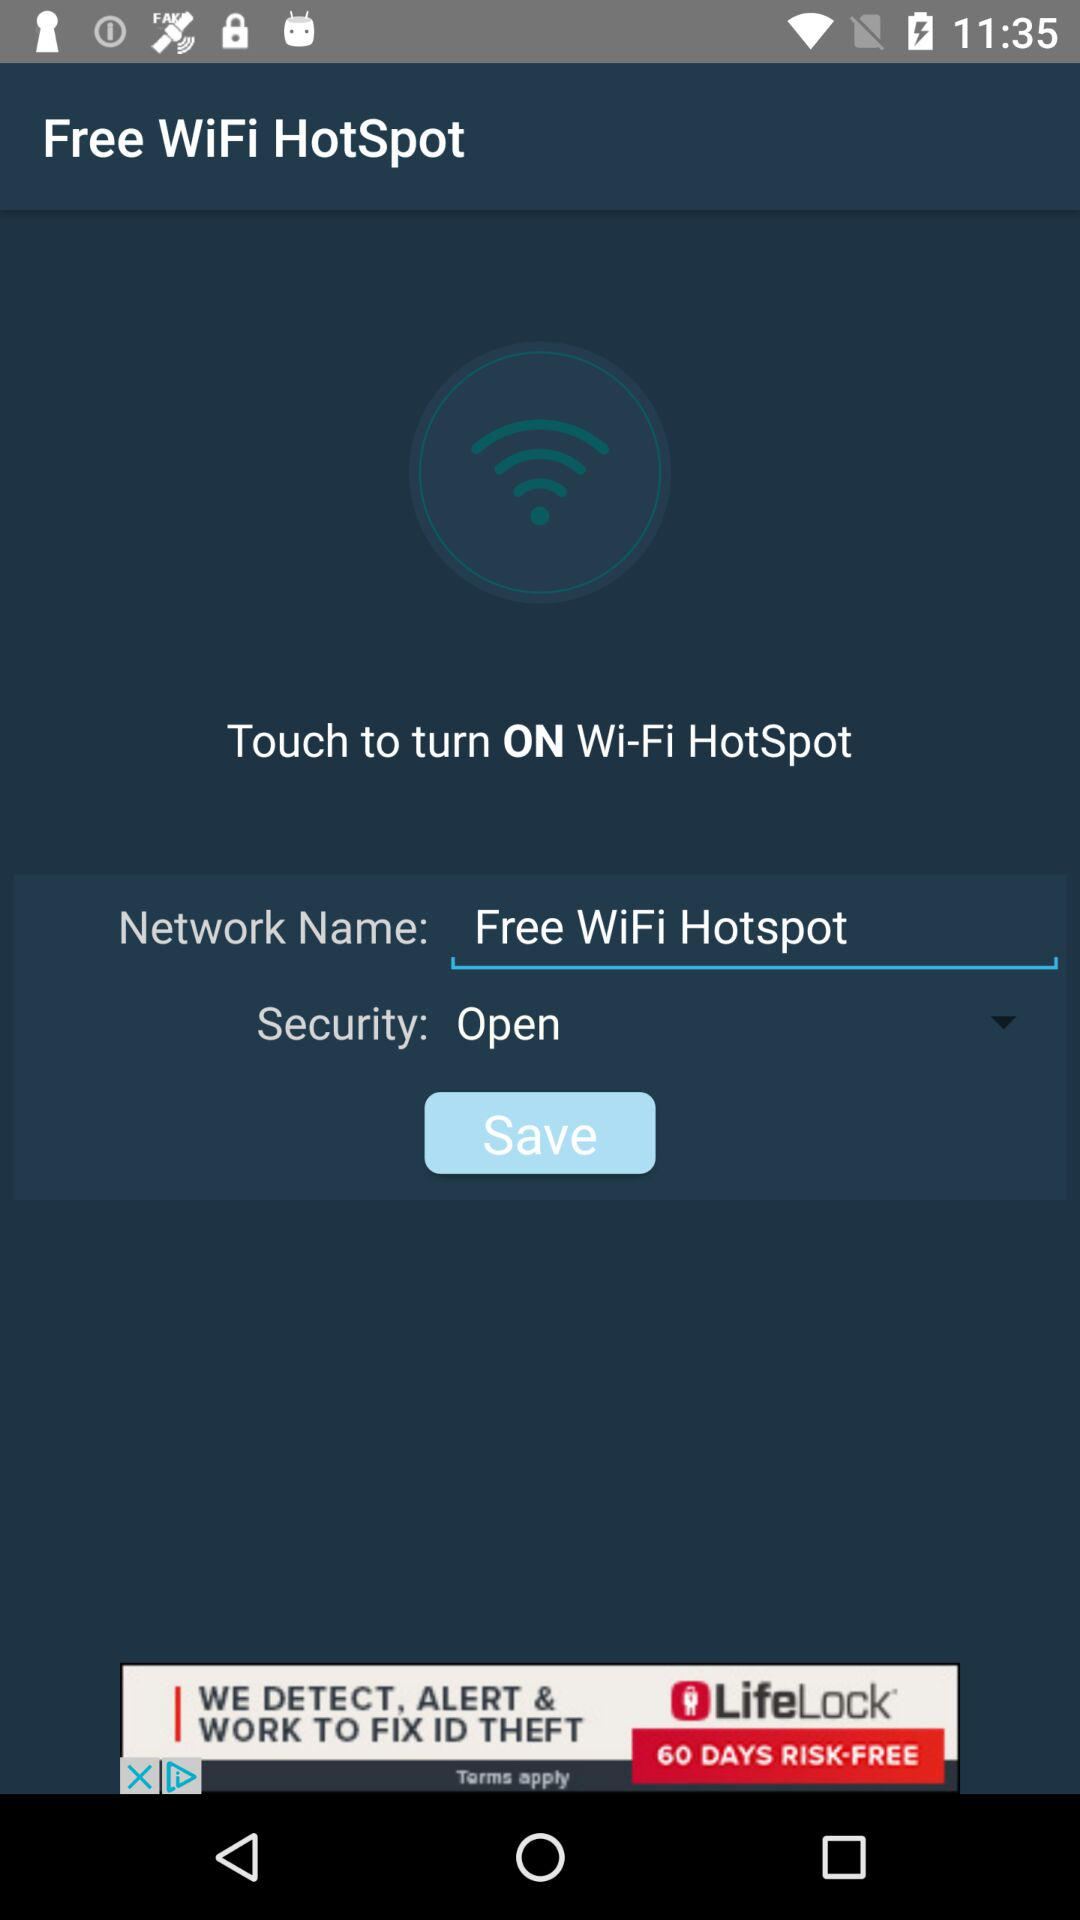What is the selected security type? The selected security type is "Open". 